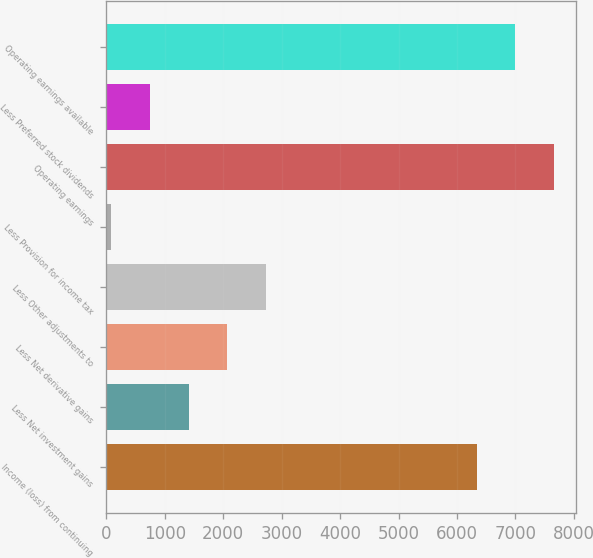<chart> <loc_0><loc_0><loc_500><loc_500><bar_chart><fcel>Income (loss) from continuing<fcel>Less Net investment gains<fcel>Less Net derivative gains<fcel>Less Other adjustments to<fcel>Less Provision for income tax<fcel>Operating earnings<fcel>Less Preferred stock dividends<fcel>Operating earnings available<nl><fcel>6339<fcel>1406<fcel>2065.5<fcel>2725<fcel>87<fcel>7658<fcel>746.5<fcel>6998.5<nl></chart> 